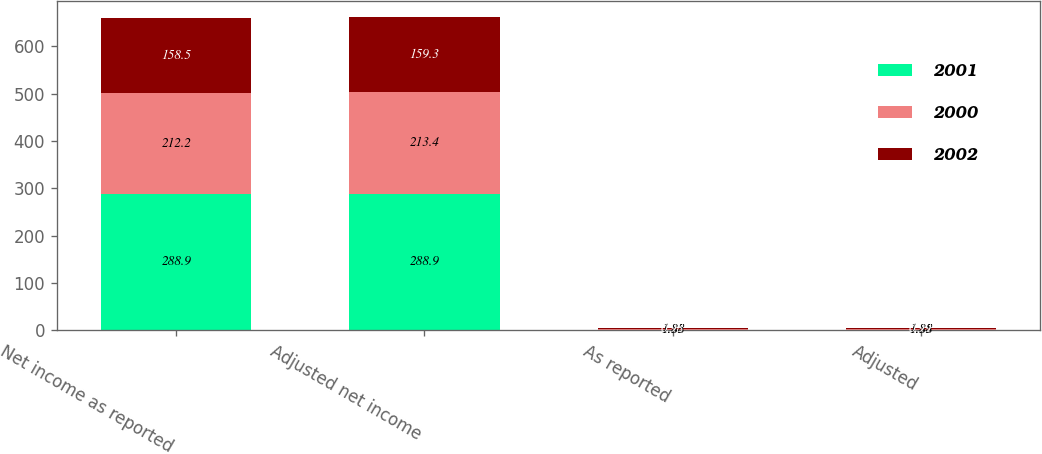Convert chart to OTSL. <chart><loc_0><loc_0><loc_500><loc_500><stacked_bar_chart><ecel><fcel>Net income as reported<fcel>Adjusted net income<fcel>As reported<fcel>Adjusted<nl><fcel>2001<fcel>288.9<fcel>288.9<fcel>1.88<fcel>1.88<nl><fcel>2000<fcel>212.2<fcel>213.4<fcel>1.35<fcel>1.35<nl><fcel>2002<fcel>158.5<fcel>159.3<fcel>0.98<fcel>0.99<nl></chart> 